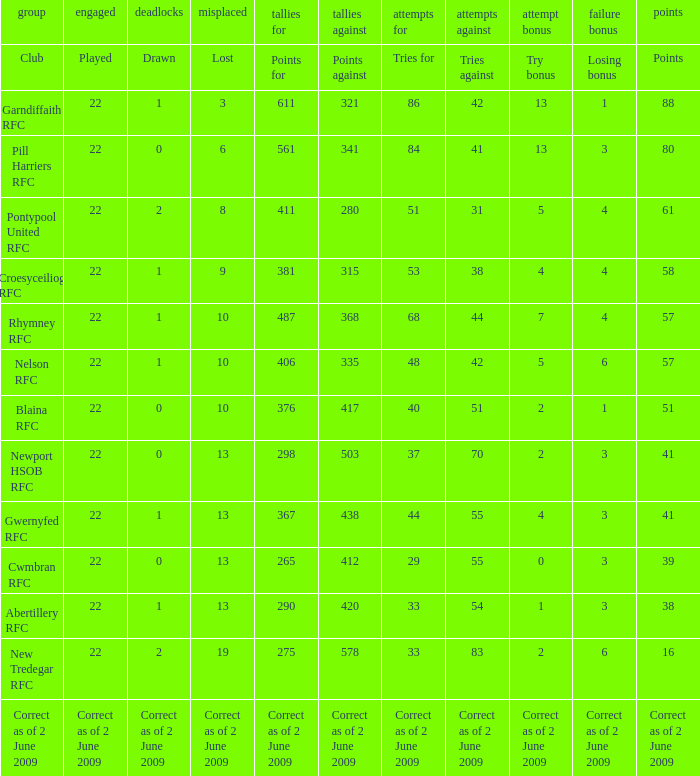Could you help me parse every detail presented in this table? {'header': ['group', 'engaged', 'deadlocks', 'misplaced', 'tallies for', 'tallies against', 'attempts for', 'attempts against', 'attempt bonus', 'failure bonus', 'points'], 'rows': [['Club', 'Played', 'Drawn', 'Lost', 'Points for', 'Points against', 'Tries for', 'Tries against', 'Try bonus', 'Losing bonus', 'Points'], ['Garndiffaith RFC', '22', '1', '3', '611', '321', '86', '42', '13', '1', '88'], ['Pill Harriers RFC', '22', '0', '6', '561', '341', '84', '41', '13', '3', '80'], ['Pontypool United RFC', '22', '2', '8', '411', '280', '51', '31', '5', '4', '61'], ['Croesyceiliog RFC', '22', '1', '9', '381', '315', '53', '38', '4', '4', '58'], ['Rhymney RFC', '22', '1', '10', '487', '368', '68', '44', '7', '4', '57'], ['Nelson RFC', '22', '1', '10', '406', '335', '48', '42', '5', '6', '57'], ['Blaina RFC', '22', '0', '10', '376', '417', '40', '51', '2', '1', '51'], ['Newport HSOB RFC', '22', '0', '13', '298', '503', '37', '70', '2', '3', '41'], ['Gwernyfed RFC', '22', '1', '13', '367', '438', '44', '55', '4', '3', '41'], ['Cwmbran RFC', '22', '0', '13', '265', '412', '29', '55', '0', '3', '39'], ['Abertillery RFC', '22', '1', '13', '290', '420', '33', '54', '1', '3', '38'], ['New Tredegar RFC', '22', '2', '19', '275', '578', '33', '83', '2', '6', '16'], ['Correct as of 2 June 2009', 'Correct as of 2 June 2009', 'Correct as of 2 June 2009', 'Correct as of 2 June 2009', 'Correct as of 2 June 2009', 'Correct as of 2 June 2009', 'Correct as of 2 June 2009', 'Correct as of 2 June 2009', 'Correct as of 2 June 2009', 'Correct as of 2 June 2009', 'Correct as of 2 June 2009']]} Which club has 275 points? New Tredegar RFC. 